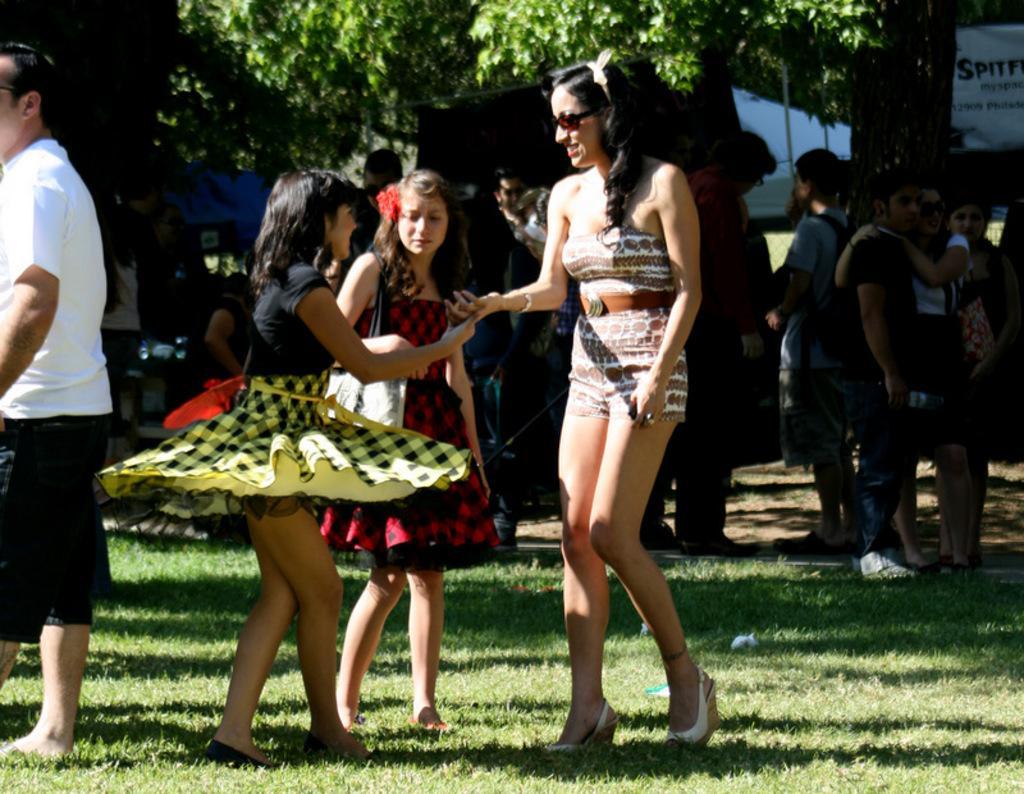Describe this image in one or two sentences. In this image we can see a few people. In the foreground we can see two women smiling. Here we can see the grass. In the background, we can see the trees. 